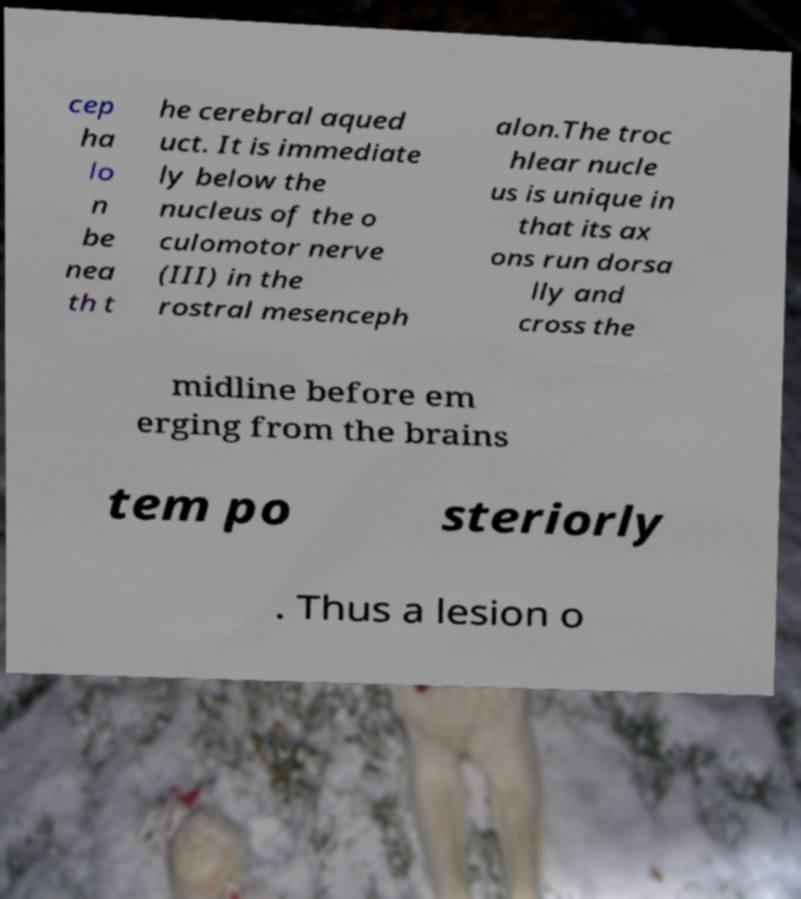Could you assist in decoding the text presented in this image and type it out clearly? cep ha lo n be nea th t he cerebral aqued uct. It is immediate ly below the nucleus of the o culomotor nerve (III) in the rostral mesenceph alon.The troc hlear nucle us is unique in that its ax ons run dorsa lly and cross the midline before em erging from the brains tem po steriorly . Thus a lesion o 